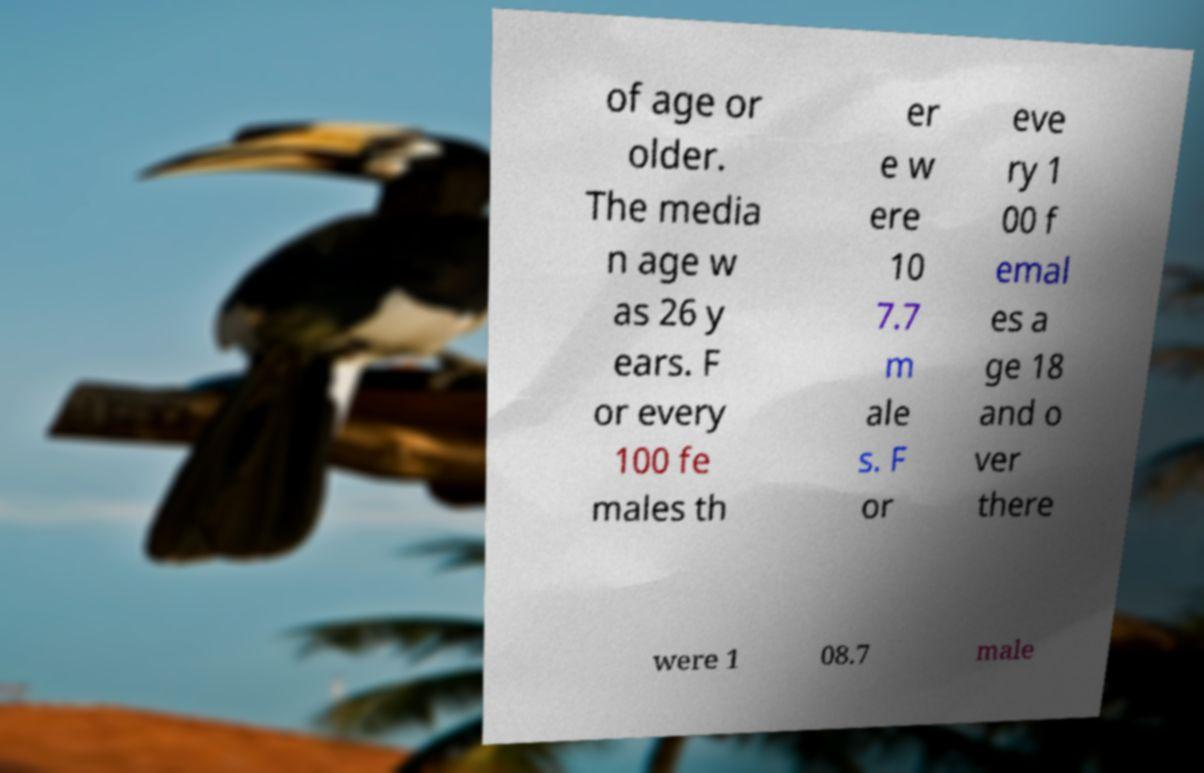Can you accurately transcribe the text from the provided image for me? of age or older. The media n age w as 26 y ears. F or every 100 fe males th er e w ere 10 7.7 m ale s. F or eve ry 1 00 f emal es a ge 18 and o ver there were 1 08.7 male 